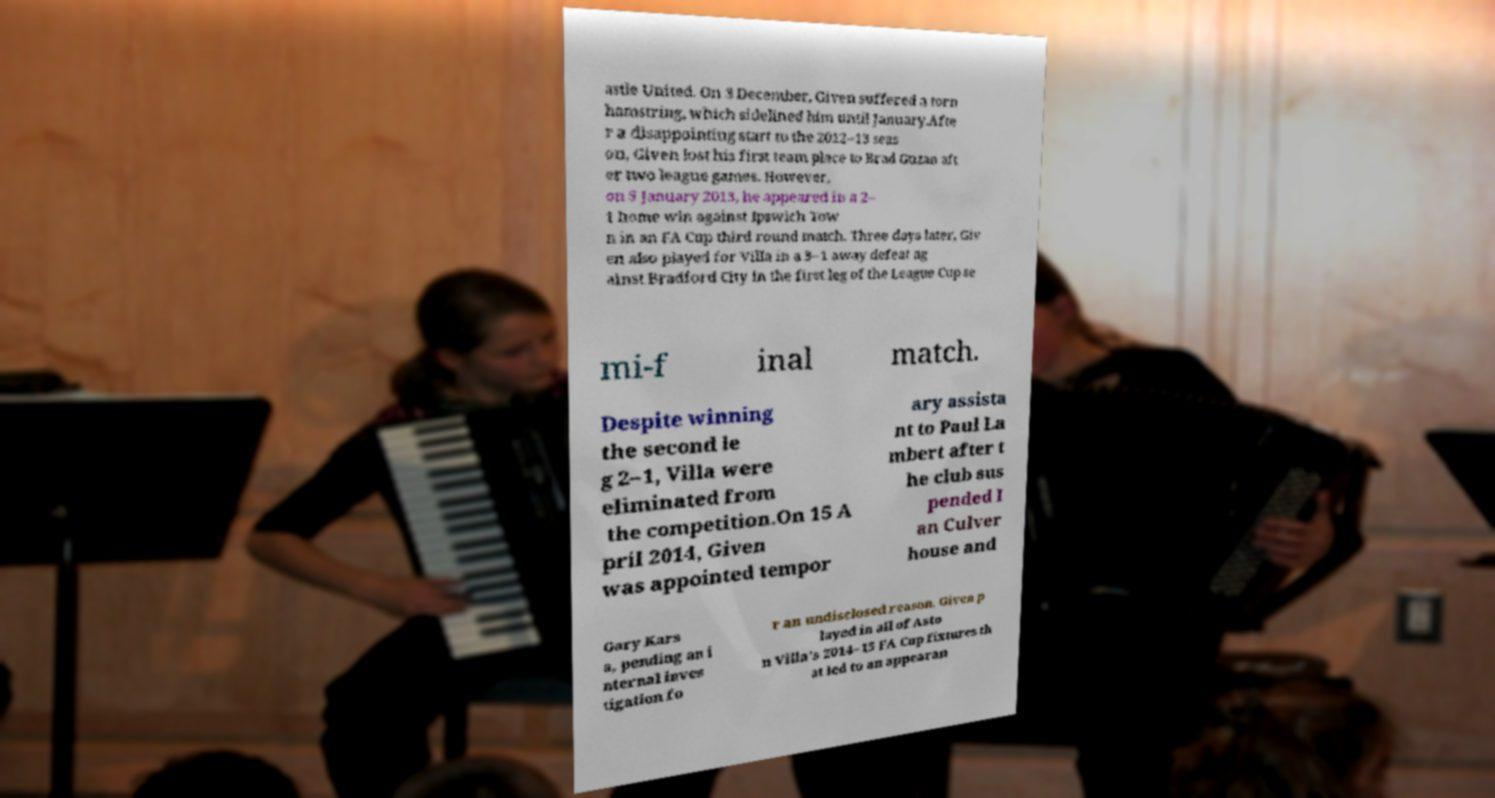Could you assist in decoding the text presented in this image and type it out clearly? astle United. On 3 December, Given suffered a torn hamstring, which sidelined him until January.Afte r a disappointing start to the 2012–13 seas on, Given lost his first team place to Brad Guzan aft er two league games. However, on 5 January 2013, he appeared in a 2– 1 home win against Ipswich Tow n in an FA Cup third round match. Three days later, Giv en also played for Villa in a 3–1 away defeat ag ainst Bradford City in the first leg of the League Cup se mi-f inal match. Despite winning the second le g 2–1, Villa were eliminated from the competition.On 15 A pril 2014, Given was appointed tempor ary assista nt to Paul La mbert after t he club sus pended I an Culver house and Gary Kars a, pending an i nternal inves tigation fo r an undisclosed reason. Given p layed in all of Asto n Villa's 2014–15 FA Cup fixtures th at led to an appearan 